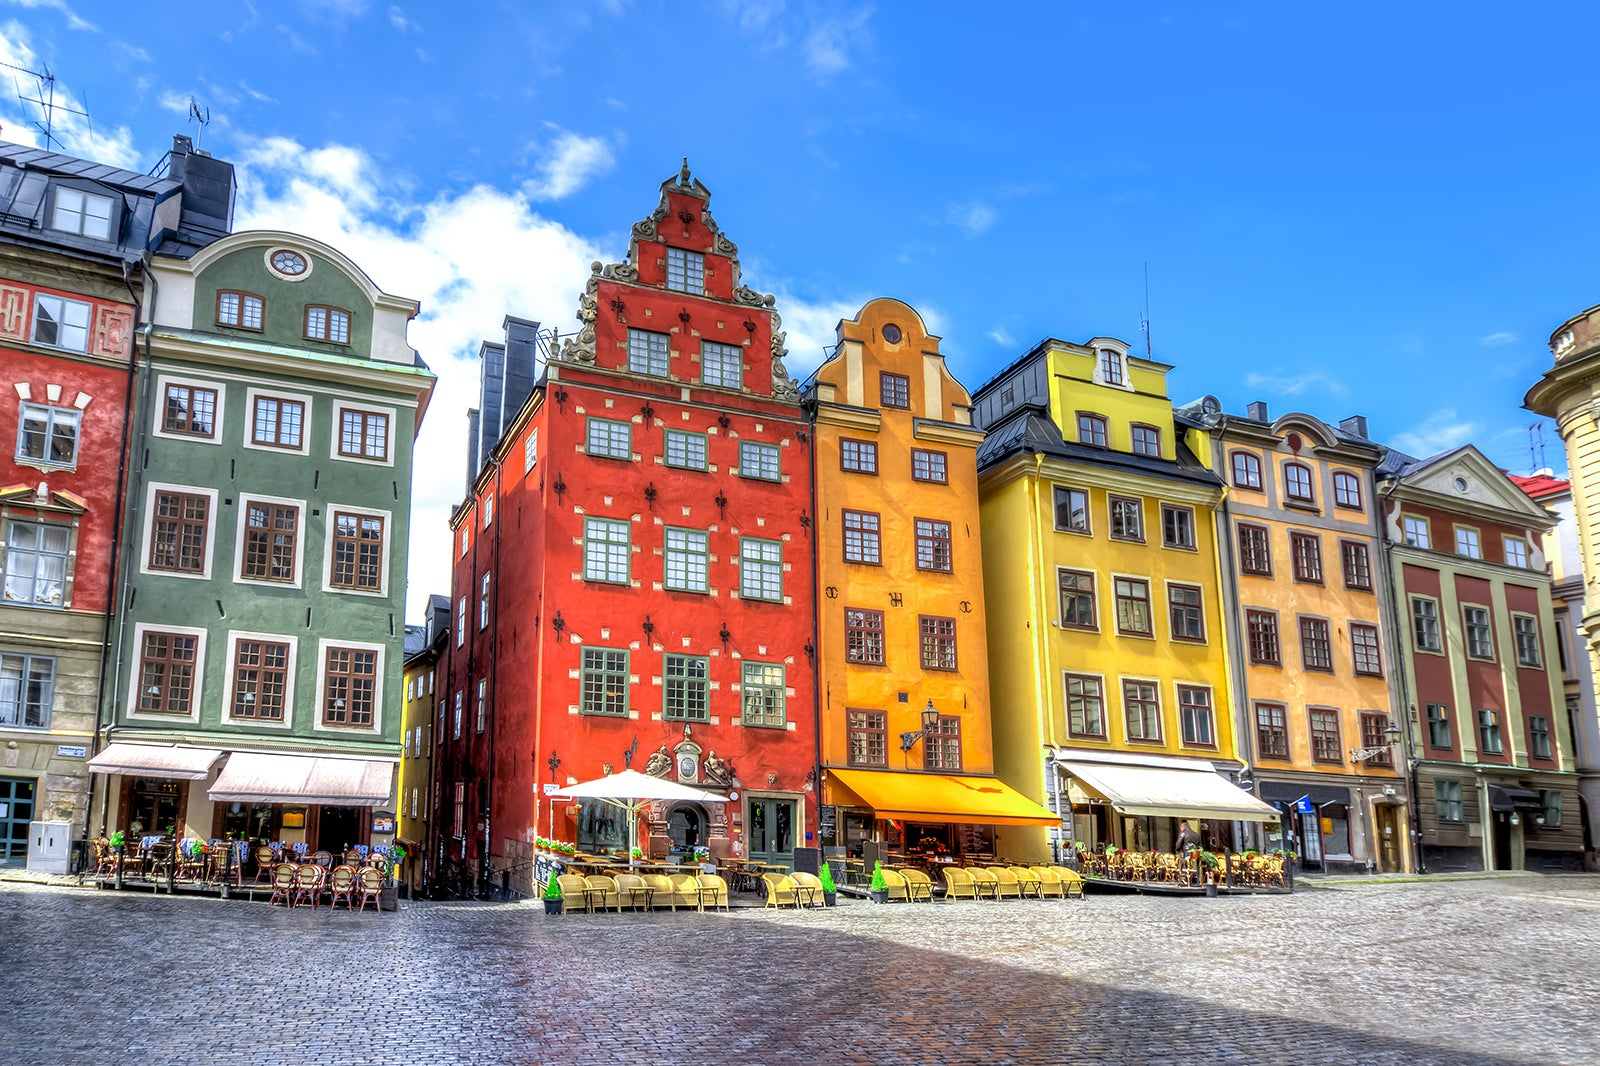What can you tell me about the cobblestone surface seen in the image? The cobblestone streets seen in the image are a characteristic feature of Gamla Stan, adding to the area's historic charm and ambience. Cobblestones were commonly used in Europe during the medieval period, and many streets in Gamla Stan retain this original stonework. This type of pavement not only contributes to the aesthetic authenticity of the district but also represents the centuries-old urban design preserved in Stockholm. Walking these streets is like traveling back in time, offering a tactile sense of history. 